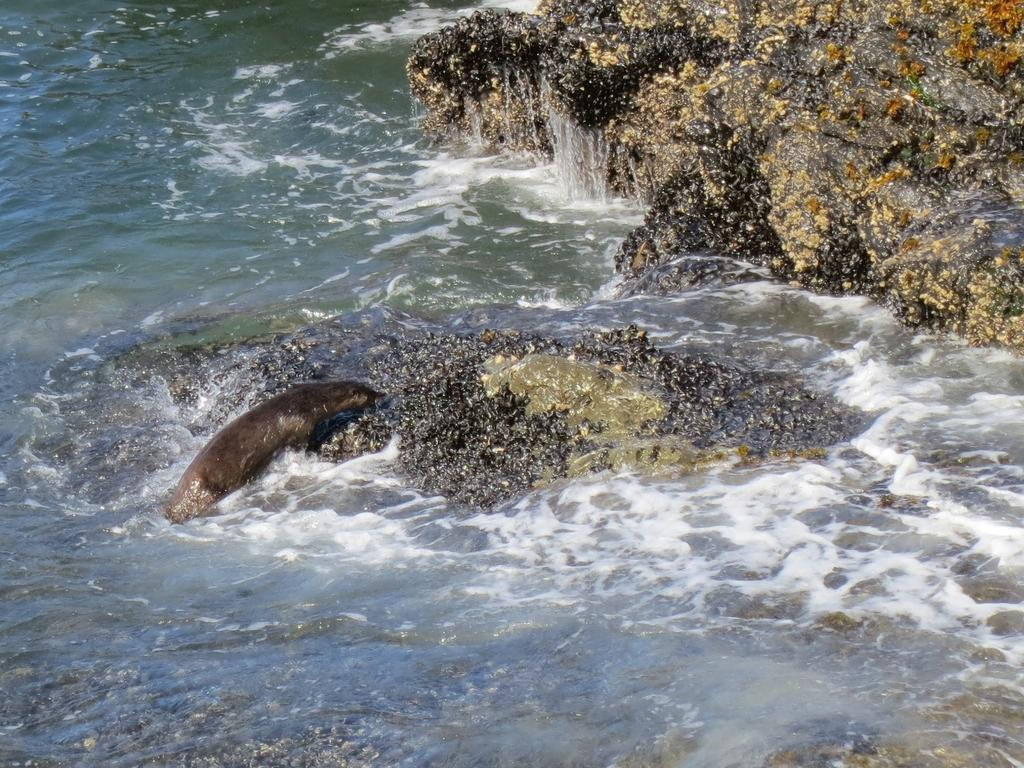What is happening in the image? There is water flowing in the image, and it is flowing over rocks. Can you describe the water in the image? The water is flowing over a rock surface that is visible in the water. Are there any living creatures in the water? Yes, there is a dolphin fish in the water. What is the color of the dolphin fish? The dolphin fish is black in color. What type of linen is being used to dry the dolphin fish after the love scene in the image? There is no linen or love scene present in the image; it features water flowing over rocks with a black dolphin fish. 